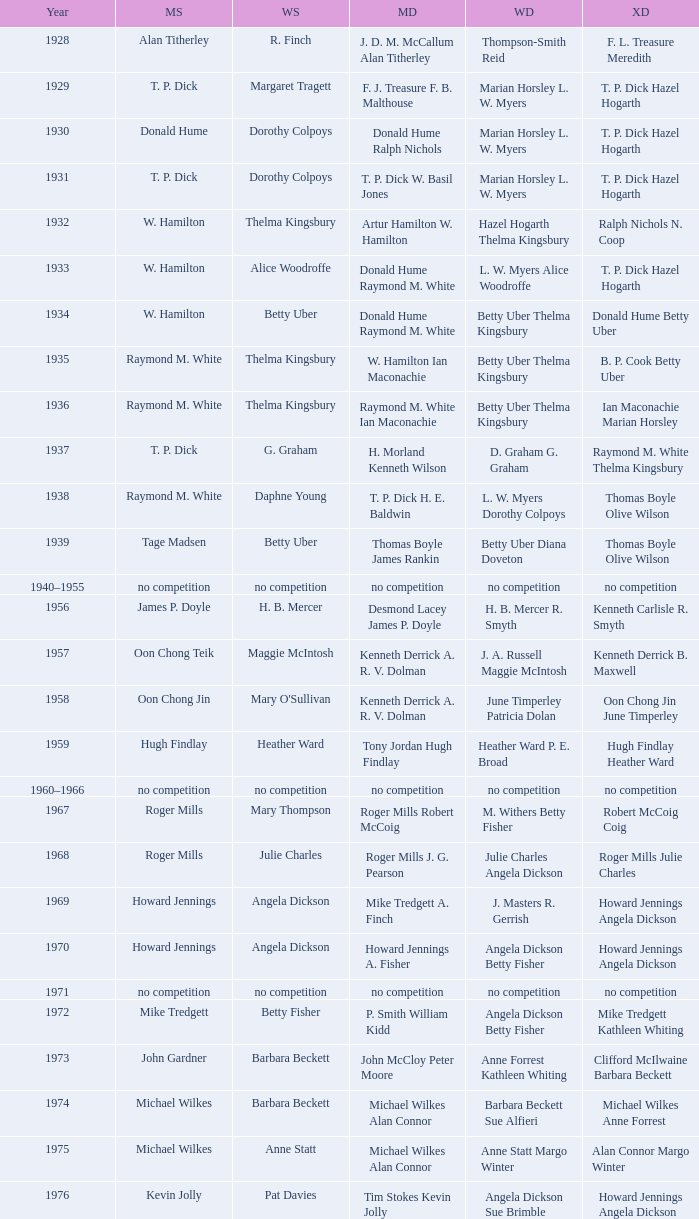Who won the Women's doubles in the year that David Eddy Eddy Sutton won the Men's doubles, and that David Eddy won the Men's singles? Anne Statt Jane Webster. Help me parse the entirety of this table. {'header': ['Year', 'MS', 'WS', 'MD', 'WD', 'XD'], 'rows': [['1928', 'Alan Titherley', 'R. Finch', 'J. D. M. McCallum Alan Titherley', 'Thompson-Smith Reid', 'F. L. Treasure Meredith'], ['1929', 'T. P. Dick', 'Margaret Tragett', 'F. J. Treasure F. B. Malthouse', 'Marian Horsley L. W. Myers', 'T. P. Dick Hazel Hogarth'], ['1930', 'Donald Hume', 'Dorothy Colpoys', 'Donald Hume Ralph Nichols', 'Marian Horsley L. W. Myers', 'T. P. Dick Hazel Hogarth'], ['1931', 'T. P. Dick', 'Dorothy Colpoys', 'T. P. Dick W. Basil Jones', 'Marian Horsley L. W. Myers', 'T. P. Dick Hazel Hogarth'], ['1932', 'W. Hamilton', 'Thelma Kingsbury', 'Artur Hamilton W. Hamilton', 'Hazel Hogarth Thelma Kingsbury', 'Ralph Nichols N. Coop'], ['1933', 'W. Hamilton', 'Alice Woodroffe', 'Donald Hume Raymond M. White', 'L. W. Myers Alice Woodroffe', 'T. P. Dick Hazel Hogarth'], ['1934', 'W. Hamilton', 'Betty Uber', 'Donald Hume Raymond M. White', 'Betty Uber Thelma Kingsbury', 'Donald Hume Betty Uber'], ['1935', 'Raymond M. White', 'Thelma Kingsbury', 'W. Hamilton Ian Maconachie', 'Betty Uber Thelma Kingsbury', 'B. P. Cook Betty Uber'], ['1936', 'Raymond M. White', 'Thelma Kingsbury', 'Raymond M. White Ian Maconachie', 'Betty Uber Thelma Kingsbury', 'Ian Maconachie Marian Horsley'], ['1937', 'T. P. Dick', 'G. Graham', 'H. Morland Kenneth Wilson', 'D. Graham G. Graham', 'Raymond M. White Thelma Kingsbury'], ['1938', 'Raymond M. White', 'Daphne Young', 'T. P. Dick H. E. Baldwin', 'L. W. Myers Dorothy Colpoys', 'Thomas Boyle Olive Wilson'], ['1939', 'Tage Madsen', 'Betty Uber', 'Thomas Boyle James Rankin', 'Betty Uber Diana Doveton', 'Thomas Boyle Olive Wilson'], ['1940–1955', 'no competition', 'no competition', 'no competition', 'no competition', 'no competition'], ['1956', 'James P. Doyle', 'H. B. Mercer', 'Desmond Lacey James P. Doyle', 'H. B. Mercer R. Smyth', 'Kenneth Carlisle R. Smyth'], ['1957', 'Oon Chong Teik', 'Maggie McIntosh', 'Kenneth Derrick A. R. V. Dolman', 'J. A. Russell Maggie McIntosh', 'Kenneth Derrick B. Maxwell'], ['1958', 'Oon Chong Jin', "Mary O'Sullivan", 'Kenneth Derrick A. R. V. Dolman', 'June Timperley Patricia Dolan', 'Oon Chong Jin June Timperley'], ['1959', 'Hugh Findlay', 'Heather Ward', 'Tony Jordan Hugh Findlay', 'Heather Ward P. E. Broad', 'Hugh Findlay Heather Ward'], ['1960–1966', 'no competition', 'no competition', 'no competition', 'no competition', 'no competition'], ['1967', 'Roger Mills', 'Mary Thompson', 'Roger Mills Robert McCoig', 'M. Withers Betty Fisher', 'Robert McCoig Coig'], ['1968', 'Roger Mills', 'Julie Charles', 'Roger Mills J. G. Pearson', 'Julie Charles Angela Dickson', 'Roger Mills Julie Charles'], ['1969', 'Howard Jennings', 'Angela Dickson', 'Mike Tredgett A. Finch', 'J. Masters R. Gerrish', 'Howard Jennings Angela Dickson'], ['1970', 'Howard Jennings', 'Angela Dickson', 'Howard Jennings A. Fisher', 'Angela Dickson Betty Fisher', 'Howard Jennings Angela Dickson'], ['1971', 'no competition', 'no competition', 'no competition', 'no competition', 'no competition'], ['1972', 'Mike Tredgett', 'Betty Fisher', 'P. Smith William Kidd', 'Angela Dickson Betty Fisher', 'Mike Tredgett Kathleen Whiting'], ['1973', 'John Gardner', 'Barbara Beckett', 'John McCloy Peter Moore', 'Anne Forrest Kathleen Whiting', 'Clifford McIlwaine Barbara Beckett'], ['1974', 'Michael Wilkes', 'Barbara Beckett', 'Michael Wilkes Alan Connor', 'Barbara Beckett Sue Alfieri', 'Michael Wilkes Anne Forrest'], ['1975', 'Michael Wilkes', 'Anne Statt', 'Michael Wilkes Alan Connor', 'Anne Statt Margo Winter', 'Alan Connor Margo Winter'], ['1976', 'Kevin Jolly', 'Pat Davies', 'Tim Stokes Kevin Jolly', 'Angela Dickson Sue Brimble', 'Howard Jennings Angela Dickson'], ['1977', 'David Eddy', 'Paula Kilvington', 'David Eddy Eddy Sutton', 'Anne Statt Jane Webster', 'David Eddy Barbara Giles'], ['1978', 'Mike Tredgett', 'Gillian Gilks', 'David Eddy Eddy Sutton', 'Barbara Sutton Marjan Ridder', 'Elliot Stuart Gillian Gilks'], ['1979', 'Kevin Jolly', 'Nora Perry', 'Ray Stevens Mike Tredgett', 'Barbara Sutton Nora Perry', 'Mike Tredgett Nora Perry'], ['1980', 'Thomas Kihlström', 'Jane Webster', 'Thomas Kihlström Bengt Fröman', 'Jane Webster Karen Puttick', 'Billy Gilliland Karen Puttick'], ['1981', 'Ray Stevens', 'Gillian Gilks', 'Ray Stevens Mike Tredgett', 'Gillian Gilks Paula Kilvington', 'Mike Tredgett Nora Perry'], ['1982', 'Steve Baddeley', 'Karen Bridge', 'David Eddy Eddy Sutton', 'Karen Chapman Sally Podger', 'Billy Gilliland Karen Chapman'], ['1983', 'Steve Butler', 'Sally Podger', 'Mike Tredgett Dipak Tailor', 'Nora Perry Jane Webster', 'Dipak Tailor Nora Perry'], ['1984', 'Steve Butler', 'Karen Beckman', 'Mike Tredgett Martin Dew', 'Helen Troke Karen Chapman', 'Mike Tredgett Karen Chapman'], ['1985', 'Morten Frost', 'Charlotte Hattens', 'Billy Gilliland Dan Travers', 'Gillian Gilks Helen Troke', 'Martin Dew Gillian Gilks'], ['1986', 'Darren Hall', 'Fiona Elliott', 'Martin Dew Dipak Tailor', 'Karen Beckman Sara Halsall', 'Jesper Knudsen Nettie Nielsen'], ['1987', 'Darren Hall', 'Fiona Elliott', 'Martin Dew Darren Hall', 'Karen Beckman Sara Halsall', 'Martin Dew Gillian Gilks'], ['1988', 'Vimal Kumar', 'Lee Jung-mi', 'Richard Outterside Mike Brown', 'Fiona Elliott Sara Halsall', 'Martin Dew Gillian Gilks'], ['1989', 'Darren Hall', 'Bang Soo-hyun', 'Nick Ponting Dave Wright', 'Karen Beckman Sara Sankey', 'Mike Brown Jillian Wallwork'], ['1990', 'Mathew Smith', 'Joanne Muggeridge', 'Nick Ponting Dave Wright', 'Karen Chapman Sara Sankey', 'Dave Wright Claire Palmer'], ['1991', 'Vimal Kumar', 'Denyse Julien', 'Nick Ponting Dave Wright', 'Cheryl Johnson Julie Bradbury', 'Nick Ponting Joanne Wright'], ['1992', 'Wei Yan', 'Fiona Smith', 'Michael Adams Chris Rees', 'Denyse Julien Doris Piché', 'Andy Goode Joanne Wright'], ['1993', 'Anders Nielsen', 'Sue Louis Lane', 'Nick Ponting Dave Wright', 'Julie Bradbury Sara Sankey', 'Nick Ponting Joanne Wright'], ['1994', 'Darren Hall', 'Marina Andrievskaya', 'Michael Adams Simon Archer', 'Julie Bradbury Joanne Wright', 'Chris Hunt Joanne Wright'], ['1995', 'Peter Rasmussen', 'Denyse Julien', 'Andrei Andropov Nikolai Zuyev', 'Julie Bradbury Joanne Wright', 'Nick Ponting Joanne Wright'], ['1996', 'Colin Haughton', 'Elena Rybkina', 'Andrei Andropov Nikolai Zuyev', 'Elena Rybkina Marina Yakusheva', 'Nikolai Zuyev Marina Yakusheva'], ['1997', 'Chris Bruil', 'Kelly Morgan', 'Ian Pearson James Anderson', 'Nicole van Hooren Brenda Conijn', 'Quinten van Dalm Nicole van Hooren'], ['1998', 'Dicky Palyama', 'Brenda Beenhakker', 'James Anderson Ian Sullivan', 'Sara Sankey Ella Tripp', 'James Anderson Sara Sankey'], ['1999', 'Daniel Eriksson', 'Marina Andrievskaya', 'Joachim Tesche Jean-Philippe Goyette', 'Marina Andrievskaya Catrine Bengtsson', 'Henrik Andersson Marina Andrievskaya'], ['2000', 'Richard Vaughan', 'Marina Yakusheva', 'Joachim Andersson Peter Axelsson', 'Irina Ruslyakova Marina Yakusheva', 'Peter Jeffrey Joanne Davies'], ['2001', 'Irwansyah', 'Brenda Beenhakker', 'Vincent Laigle Svetoslav Stoyanov', 'Sara Sankey Ella Tripp', 'Nikolai Zuyev Marina Yakusheva'], ['2002', 'Irwansyah', 'Karina de Wit', 'Nikolai Zuyev Stanislav Pukhov', 'Ella Tripp Joanne Wright', 'Nikolai Zuyev Marina Yakusheva'], ['2003', 'Irwansyah', 'Ella Karachkova', 'Ashley Thilthorpe Kristian Roebuck', 'Ella Karachkova Anastasia Russkikh', 'Alexandr Russkikh Anastasia Russkikh'], ['2004', 'Nathan Rice', 'Petya Nedelcheva', 'Reuben Gordown Aji Basuki Sindoro', 'Petya Nedelcheva Yuan Wemyss', 'Matthew Hughes Kelly Morgan'], ['2005', 'Chetan Anand', 'Eleanor Cox', 'Andrew Ellis Dean George', 'Hayley Connor Heather Olver', 'Valiyaveetil Diju Jwala Gutta'], ['2006', 'Irwansyah', 'Huang Chia-chi', 'Matthew Hughes Martyn Lewis', 'Natalie Munt Mariana Agathangelou', 'Kristian Roebuck Natalie Munt'], ['2007', 'Marc Zwiebler', 'Jill Pittard', 'Wojciech Szkudlarczyk Adam Cwalina', 'Chloe Magee Bing Huang', 'Wojciech Szkudlarczyk Malgorzata Kurdelska'], ['2008', 'Brice Leverdez', 'Kati Tolmoff', 'Andrew Bowman Martyn Lewis', 'Mariana Agathangelou Jillie Cooper', 'Watson Briggs Jillie Cooper'], ['2009', 'Kristian Nielsen', 'Tatjana Bibik', 'Vitaliy Durkin Alexandr Nikolaenko', 'Valeria Sorokina Nina Vislova', 'Vitaliy Durkin Nina Vislova'], ['2010', 'Pablo Abián', 'Anita Raj Kaur', 'Peter Käsbauer Josche Zurwonne', 'Joanne Quay Swee Ling Anita Raj Kaur', 'Peter Käsbauer Johanna Goliszewski'], ['2011', 'Niluka Karunaratne', 'Nicole Schaller', 'Chris Coles Matthew Nottingham', 'Ng Hui Ern Ng Hui Lin', 'Martin Campbell Ng Hui Lin'], ['2012', 'Chou Tien-chen', 'Chiang Mei-hui', 'Marcus Ellis Paul Van Rietvelde', 'Gabrielle White Lauren Smith', 'Marcus Ellis Gabrielle White']]} 